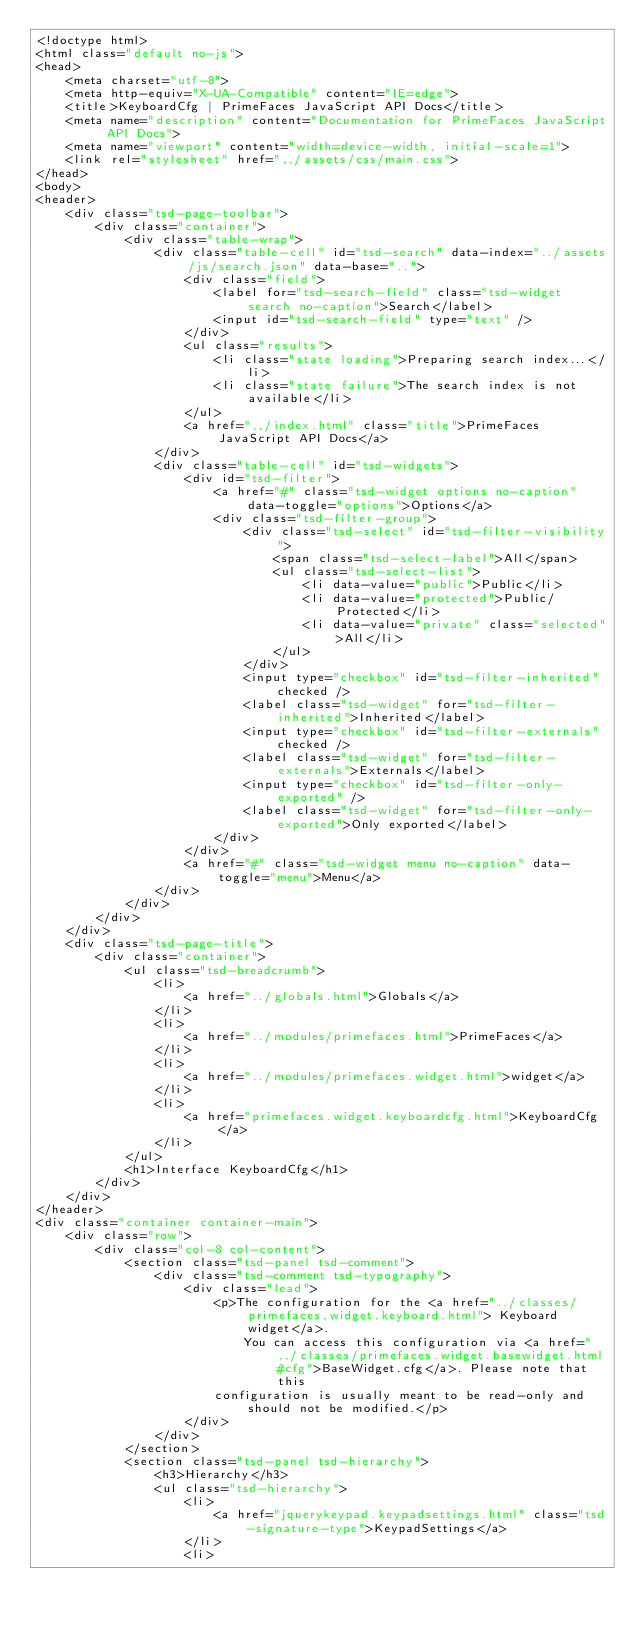Convert code to text. <code><loc_0><loc_0><loc_500><loc_500><_HTML_><!doctype html>
<html class="default no-js">
<head>
	<meta charset="utf-8">
	<meta http-equiv="X-UA-Compatible" content="IE=edge">
	<title>KeyboardCfg | PrimeFaces JavaScript API Docs</title>
	<meta name="description" content="Documentation for PrimeFaces JavaScript API Docs">
	<meta name="viewport" content="width=device-width, initial-scale=1">
	<link rel="stylesheet" href="../assets/css/main.css">
</head>
<body>
<header>
	<div class="tsd-page-toolbar">
		<div class="container">
			<div class="table-wrap">
				<div class="table-cell" id="tsd-search" data-index="../assets/js/search.json" data-base="..">
					<div class="field">
						<label for="tsd-search-field" class="tsd-widget search no-caption">Search</label>
						<input id="tsd-search-field" type="text" />
					</div>
					<ul class="results">
						<li class="state loading">Preparing search index...</li>
						<li class="state failure">The search index is not available</li>
					</ul>
					<a href="../index.html" class="title">PrimeFaces JavaScript API Docs</a>
				</div>
				<div class="table-cell" id="tsd-widgets">
					<div id="tsd-filter">
						<a href="#" class="tsd-widget options no-caption" data-toggle="options">Options</a>
						<div class="tsd-filter-group">
							<div class="tsd-select" id="tsd-filter-visibility">
								<span class="tsd-select-label">All</span>
								<ul class="tsd-select-list">
									<li data-value="public">Public</li>
									<li data-value="protected">Public/Protected</li>
									<li data-value="private" class="selected">All</li>
								</ul>
							</div>
							<input type="checkbox" id="tsd-filter-inherited" checked />
							<label class="tsd-widget" for="tsd-filter-inherited">Inherited</label>
							<input type="checkbox" id="tsd-filter-externals" checked />
							<label class="tsd-widget" for="tsd-filter-externals">Externals</label>
							<input type="checkbox" id="tsd-filter-only-exported" />
							<label class="tsd-widget" for="tsd-filter-only-exported">Only exported</label>
						</div>
					</div>
					<a href="#" class="tsd-widget menu no-caption" data-toggle="menu">Menu</a>
				</div>
			</div>
		</div>
	</div>
	<div class="tsd-page-title">
		<div class="container">
			<ul class="tsd-breadcrumb">
				<li>
					<a href="../globals.html">Globals</a>
				</li>
				<li>
					<a href="../modules/primefaces.html">PrimeFaces</a>
				</li>
				<li>
					<a href="../modules/primefaces.widget.html">widget</a>
				</li>
				<li>
					<a href="primefaces.widget.keyboardcfg.html">KeyboardCfg</a>
				</li>
			</ul>
			<h1>Interface KeyboardCfg</h1>
		</div>
	</div>
</header>
<div class="container container-main">
	<div class="row">
		<div class="col-8 col-content">
			<section class="tsd-panel tsd-comment">
				<div class="tsd-comment tsd-typography">
					<div class="lead">
						<p>The configuration for the <a href="../classes/primefaces.widget.keyboard.html"> Keyboard widget</a>.
							You can access this configuration via <a href="../classes/primefaces.widget.basewidget.html#cfg">BaseWidget.cfg</a>. Please note that this
						configuration is usually meant to be read-only and should not be modified.</p>
					</div>
				</div>
			</section>
			<section class="tsd-panel tsd-hierarchy">
				<h3>Hierarchy</h3>
				<ul class="tsd-hierarchy">
					<li>
						<a href="jquerykeypad.keypadsettings.html" class="tsd-signature-type">KeypadSettings</a>
					</li>
					<li></code> 